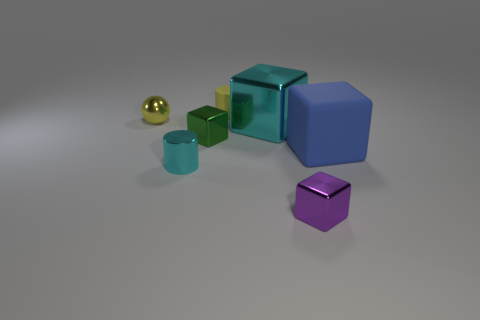What is the size of the block to the right of the small purple metallic block?
Give a very brief answer. Large. What is the shape of the cyan metallic object that is behind the large block that is on the right side of the large shiny block?
Keep it short and to the point. Cube. There is another large thing that is the same shape as the big blue rubber object; what is its color?
Provide a succinct answer. Cyan. There is a yellow object right of the yellow ball; is its size the same as the blue block?
Offer a terse response. No. The metal object that is the same color as the tiny rubber thing is what shape?
Your response must be concise. Sphere. What number of small gray balls have the same material as the purple block?
Your answer should be very brief. 0. There is a big object to the left of the tiny metallic block in front of the blue thing that is to the right of the cyan cylinder; what is its material?
Provide a short and direct response. Metal. What is the color of the tiny metal thing that is to the right of the tiny yellow thing that is behind the small yellow metallic ball?
Your answer should be compact. Purple. What color is the other cylinder that is the same size as the matte cylinder?
Provide a short and direct response. Cyan. What number of tiny objects are metal objects or blue spheres?
Provide a short and direct response. 4. 